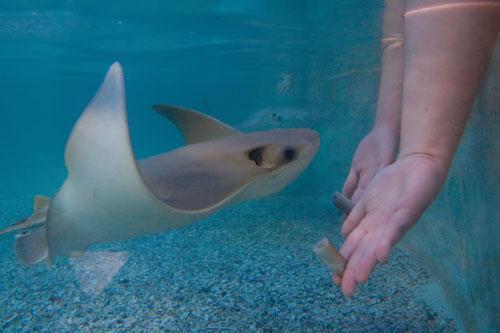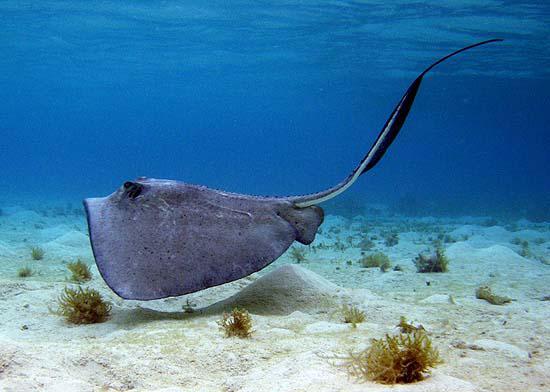The first image is the image on the left, the second image is the image on the right. For the images displayed, is the sentence "The underside of a stingray, including its mouth, is visible in the right-hand image." factually correct? Answer yes or no. No. The first image is the image on the left, the second image is the image on the right. For the images displayed, is the sentence "There are at least two rays in at least one of the images." factually correct? Answer yes or no. No. 